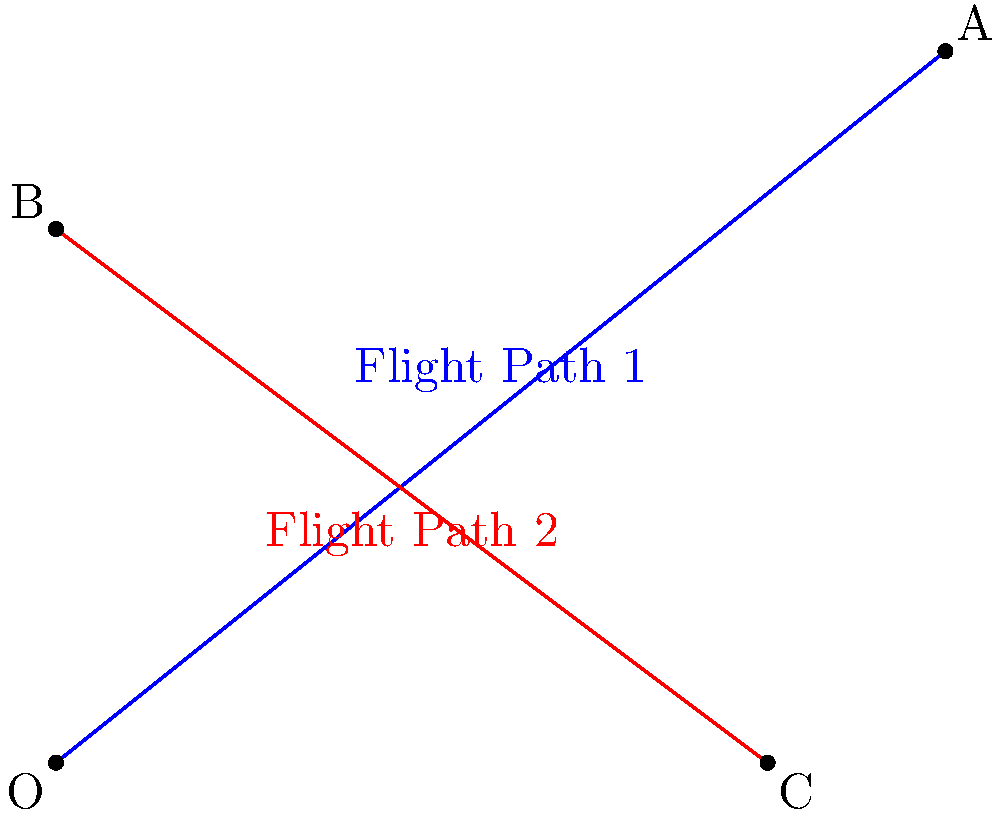As a travel agent specializing in all-inclusive vacation packages for families, you're planning a trip that involves two connecting flights. Flight Path 1 can be represented by the equation $y = \frac{4}{5}x$ and Flight Path 2 by the equation $y = -\frac{3}{4}x + 6$. At what point (in miles) do these flight paths intersect, and what is the total distance traveled to reach this intersection point from the origin? Let's solve this step-by-step:

1) To find the intersection point, we need to solve the system of equations:
   $$y = \frac{4}{5}x$$
   $$y = -\frac{3}{4}x + 6$$

2) Set the equations equal to each other:
   $$\frac{4}{5}x = -\frac{3}{4}x + 6$$

3) Multiply both sides by 20 to eliminate fractions:
   $$16x = -15x + 120$$

4) Add 15x to both sides:
   $$31x = 120$$

5) Divide both sides by 31:
   $$x = \frac{120}{31} \approx 3.87 \text{ miles}$$

6) Substitute this x-value into either original equation to find y:
   $$y = \frac{4}{5}(\frac{120}{31}) = \frac{96}{31} \approx 3.10 \text{ miles}$$

7) The intersection point I is approximately (3.87, 3.10) miles.

8) To find the total distance traveled, we need to calculate the distance from (0,0) to (3.87, 3.10):
   $$d = \sqrt{(3.87)^2 + (3.10)^2} \approx 4.96 \text{ miles}$$

Therefore, the flight paths intersect at approximately (3.87, 3.10) miles, and the total distance traveled from the origin to this point is approximately 4.96 miles.
Answer: Intersection: (3.87, 3.10) miles; Total distance: 4.96 miles 